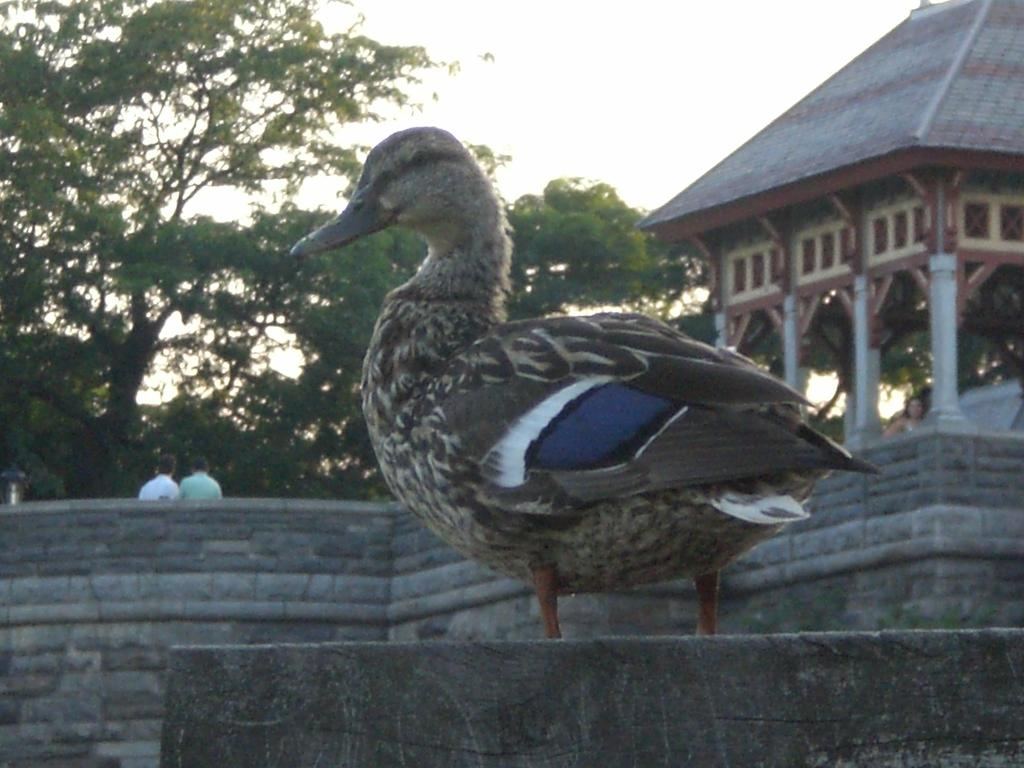What animal is present in the image? There is a duck in the image. What is located behind the duck? There is a wall behind the duck. Can you identify any human presence in the image? Yes, there are people visible in the image. What type of natural elements can be seen in the image? There are trees in the image. What type of man-made structure is present in the image? There is an architecture in the image. What is visible at the top of the image? The sky is visible at the top of the image. What type of vest is the daughter wearing in the image? There is no daughter present in the image, and therefore no one is wearing a vest. 